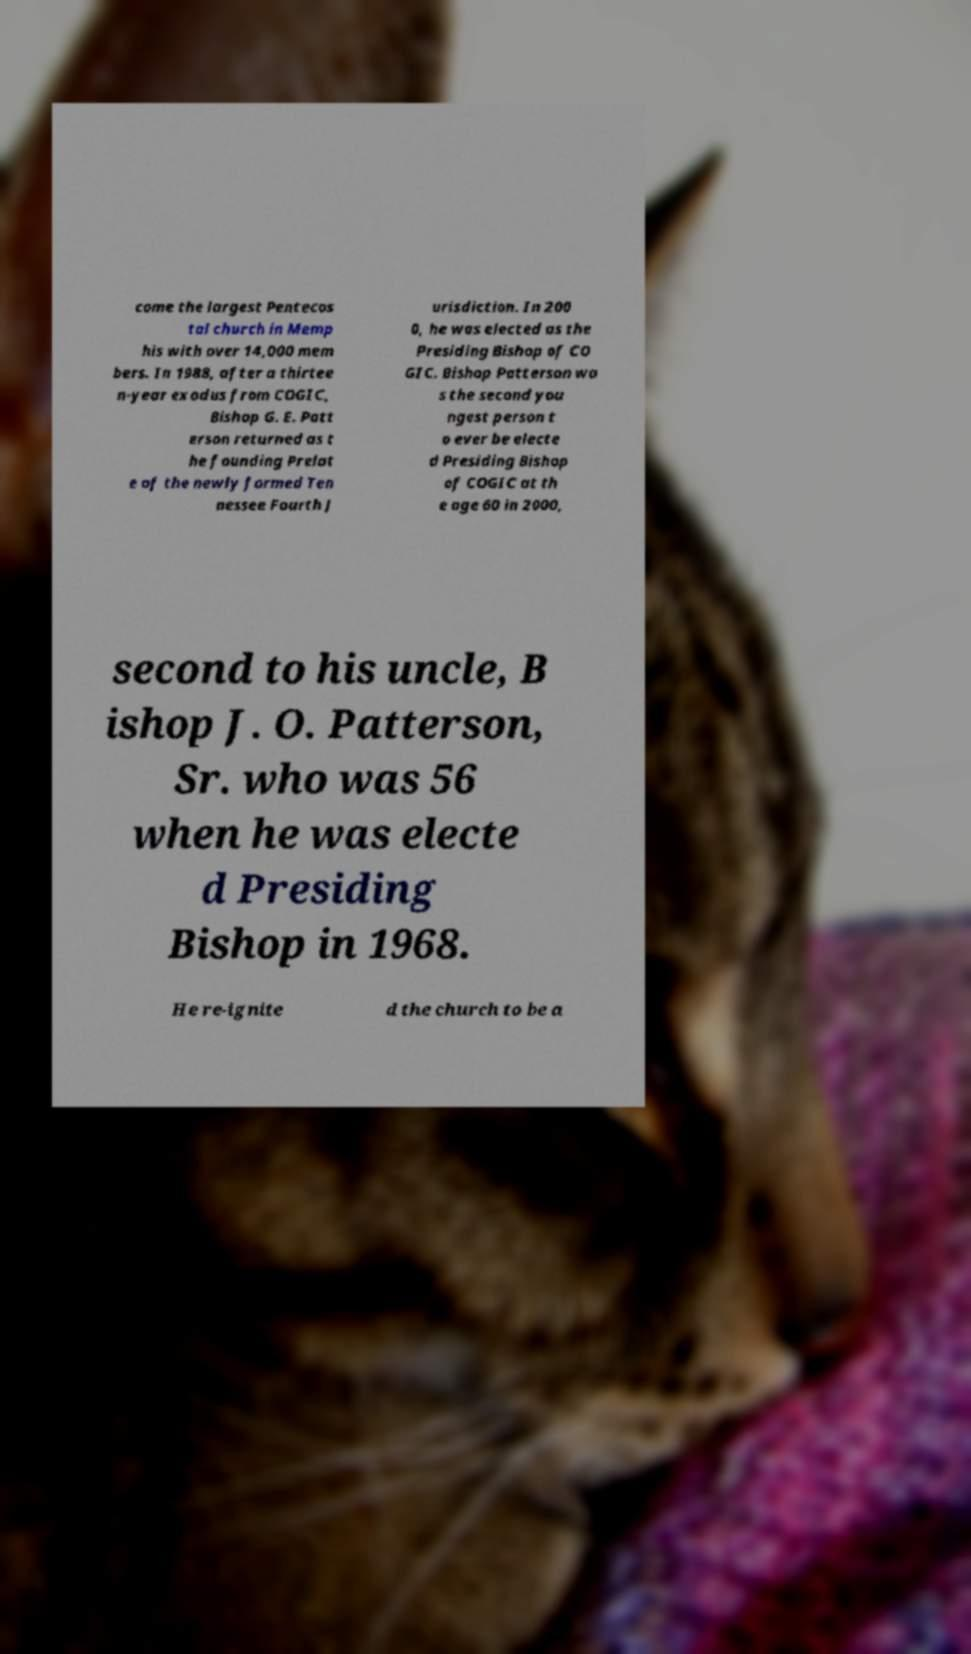Can you read and provide the text displayed in the image?This photo seems to have some interesting text. Can you extract and type it out for me? come the largest Pentecos tal church in Memp his with over 14,000 mem bers. In 1988, after a thirtee n-year exodus from COGIC, Bishop G. E. Patt erson returned as t he founding Prelat e of the newly formed Ten nessee Fourth J urisdiction. In 200 0, he was elected as the Presiding Bishop of CO GIC. Bishop Patterson wa s the second you ngest person t o ever be electe d Presiding Bishop of COGIC at th e age 60 in 2000, second to his uncle, B ishop J. O. Patterson, Sr. who was 56 when he was electe d Presiding Bishop in 1968. He re-ignite d the church to be a 